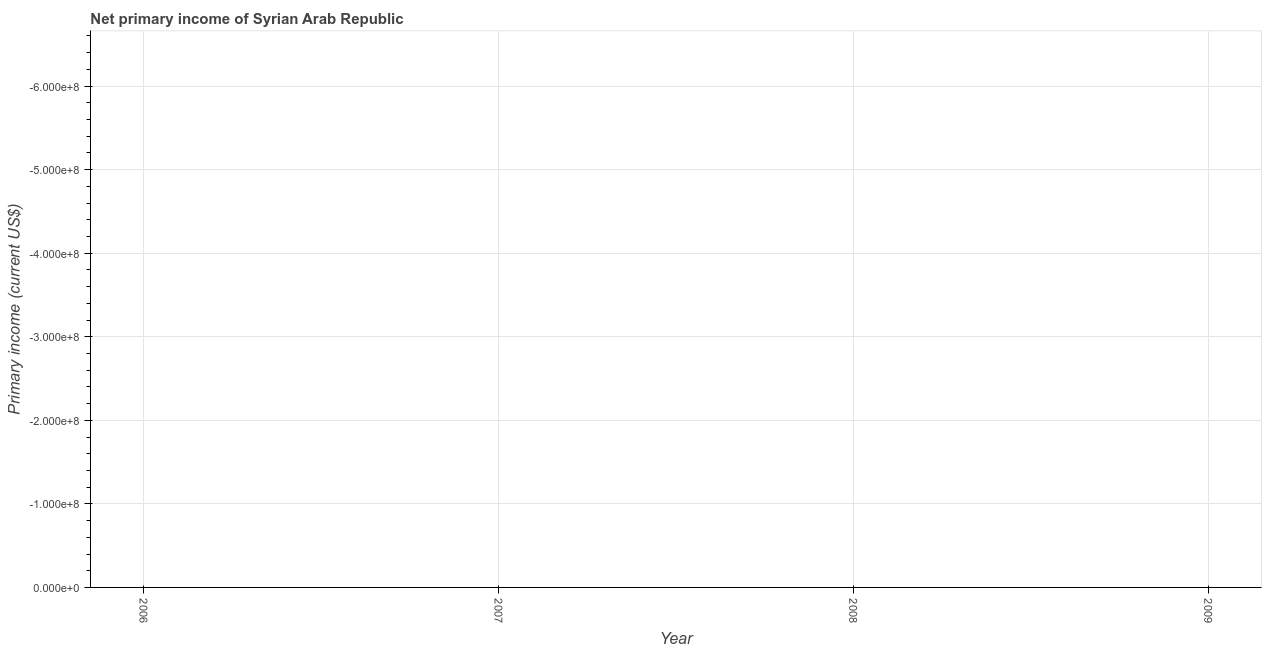What is the amount of primary income in 2008?
Provide a short and direct response. 0. Across all years, what is the minimum amount of primary income?
Keep it short and to the point. 0. What is the sum of the amount of primary income?
Your response must be concise. 0. What is the median amount of primary income?
Offer a very short reply. 0. In how many years, is the amount of primary income greater than -460000000 US$?
Your answer should be very brief. 0. How many years are there in the graph?
Make the answer very short. 4. What is the title of the graph?
Offer a terse response. Net primary income of Syrian Arab Republic. What is the label or title of the X-axis?
Provide a short and direct response. Year. What is the label or title of the Y-axis?
Your answer should be very brief. Primary income (current US$). What is the Primary income (current US$) in 2007?
Give a very brief answer. 0. What is the Primary income (current US$) in 2008?
Keep it short and to the point. 0. 